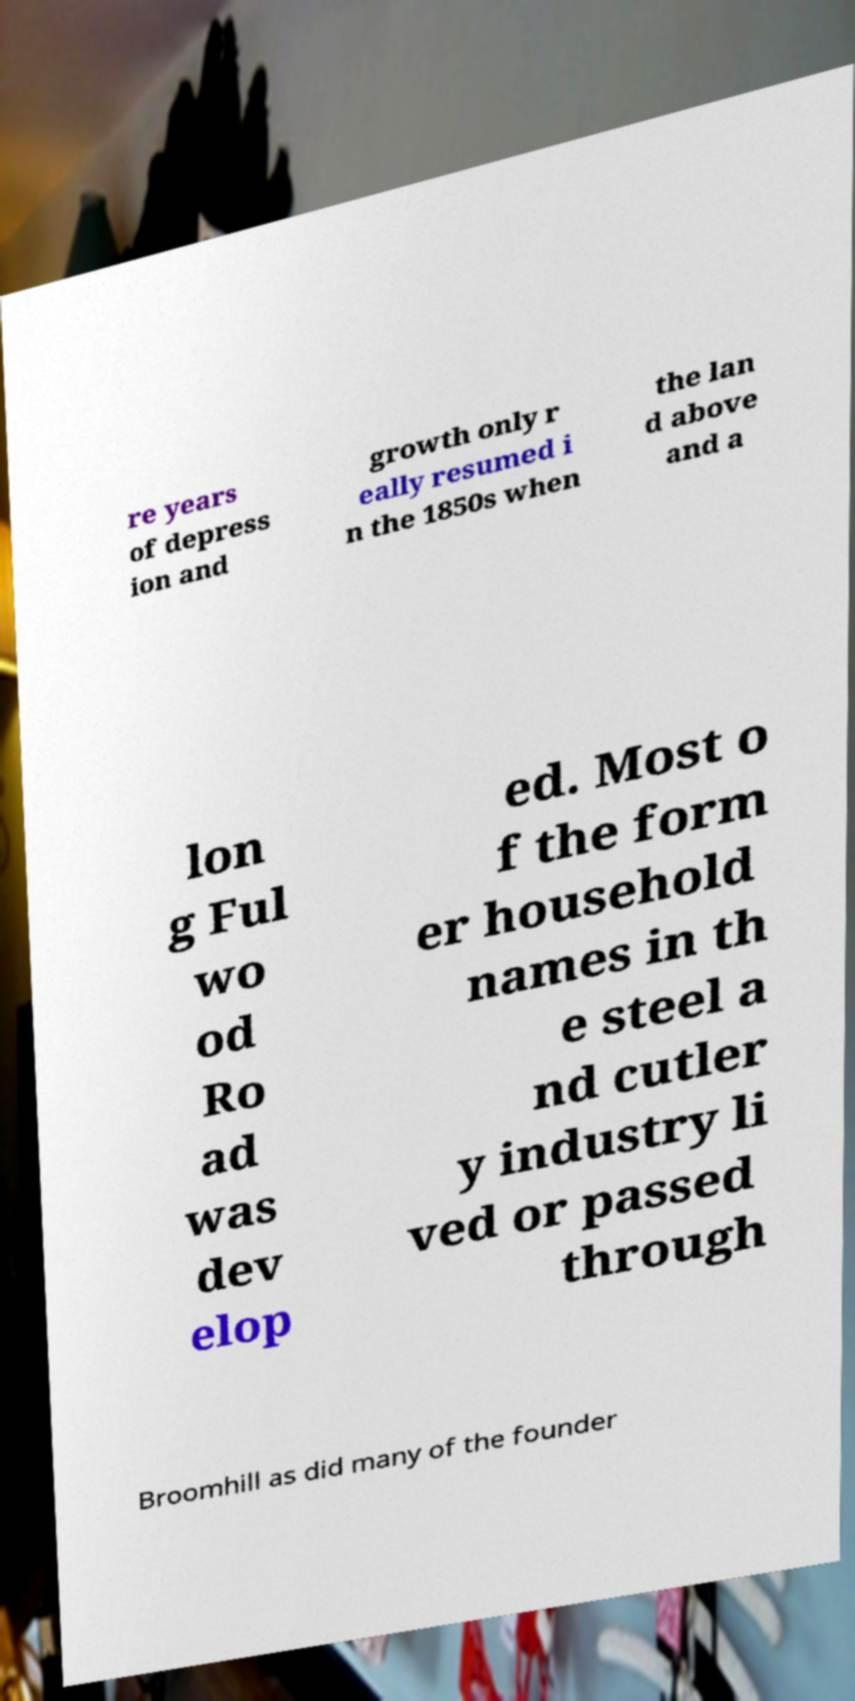Please identify and transcribe the text found in this image. re years of depress ion and growth only r eally resumed i n the 1850s when the lan d above and a lon g Ful wo od Ro ad was dev elop ed. Most o f the form er household names in th e steel a nd cutler y industry li ved or passed through Broomhill as did many of the founder 